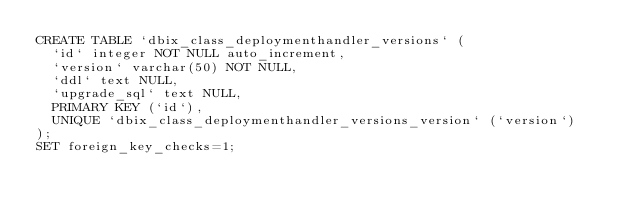<code> <loc_0><loc_0><loc_500><loc_500><_SQL_>CREATE TABLE `dbix_class_deploymenthandler_versions` (
  `id` integer NOT NULL auto_increment,
  `version` varchar(50) NOT NULL,
  `ddl` text NULL,
  `upgrade_sql` text NULL,
  PRIMARY KEY (`id`),
  UNIQUE `dbix_class_deploymenthandler_versions_version` (`version`)
);
SET foreign_key_checks=1;
</code> 